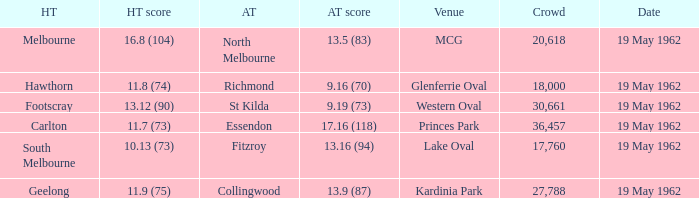What is the away team's score when the home team scores 16.8 (104)? 13.5 (83). 